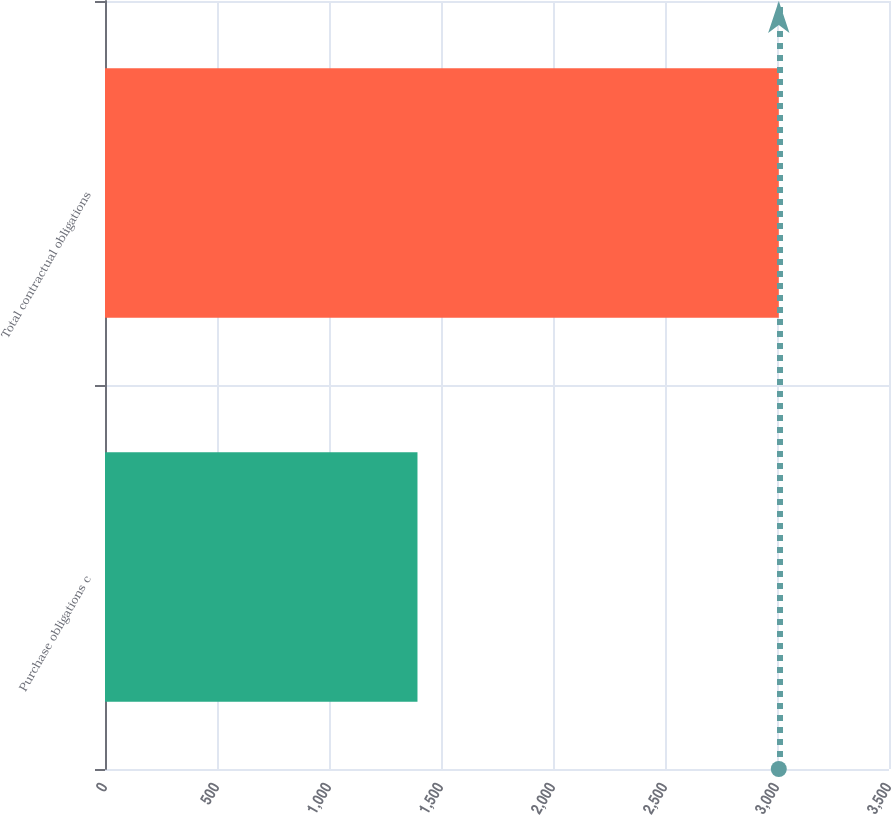Convert chart to OTSL. <chart><loc_0><loc_0><loc_500><loc_500><bar_chart><fcel>Purchase obligations c<fcel>Total contractual obligations<nl><fcel>1395<fcel>3008<nl></chart> 